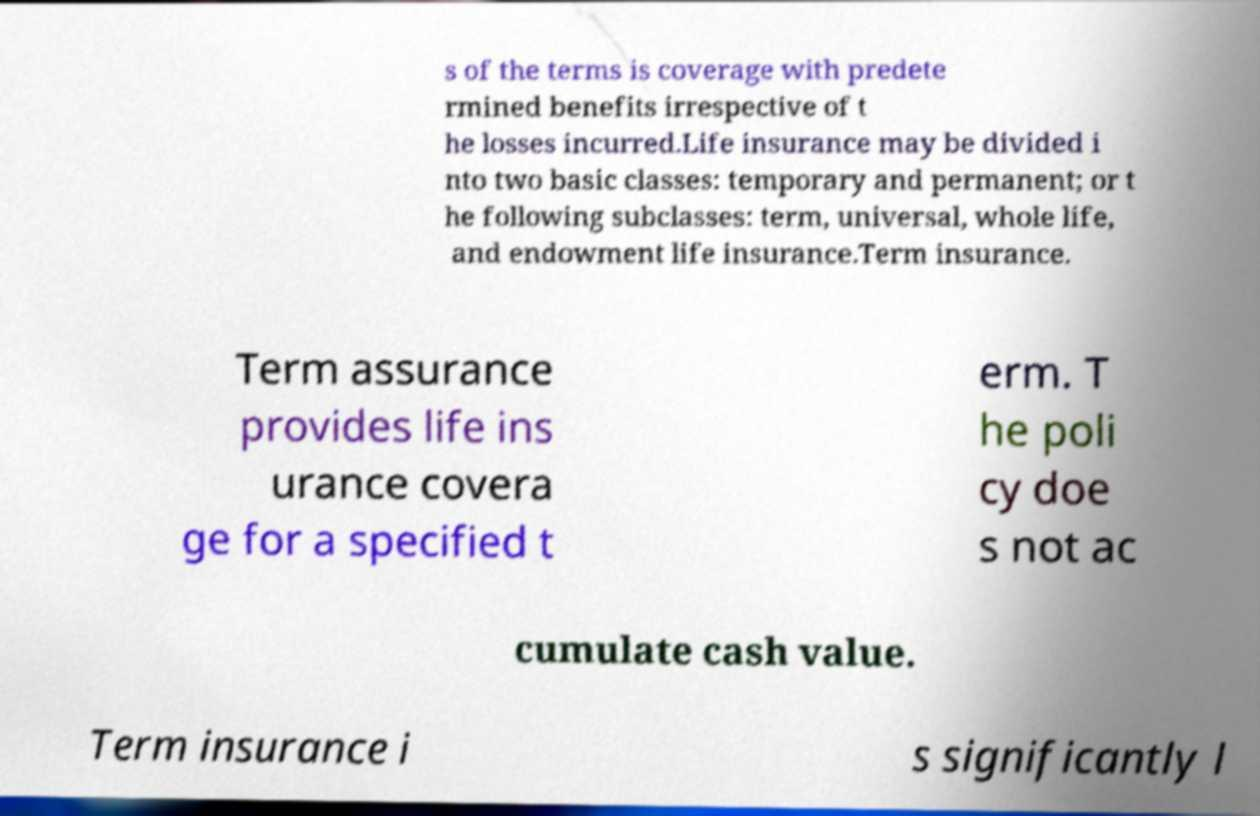What messages or text are displayed in this image? I need them in a readable, typed format. s of the terms is coverage with predete rmined benefits irrespective of t he losses incurred.Life insurance may be divided i nto two basic classes: temporary and permanent; or t he following subclasses: term, universal, whole life, and endowment life insurance.Term insurance. Term assurance provides life ins urance covera ge for a specified t erm. T he poli cy doe s not ac cumulate cash value. Term insurance i s significantly l 